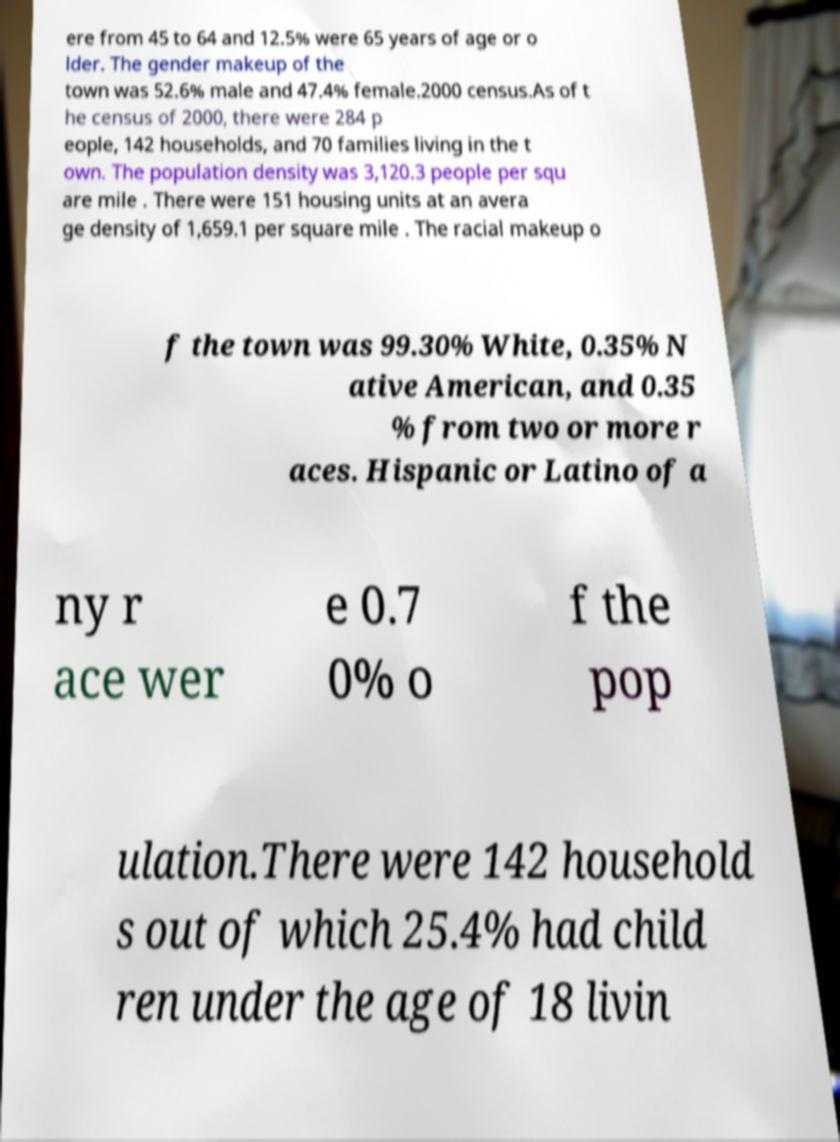Could you assist in decoding the text presented in this image and type it out clearly? ere from 45 to 64 and 12.5% were 65 years of age or o lder. The gender makeup of the town was 52.6% male and 47.4% female.2000 census.As of t he census of 2000, there were 284 p eople, 142 households, and 70 families living in the t own. The population density was 3,120.3 people per squ are mile . There were 151 housing units at an avera ge density of 1,659.1 per square mile . The racial makeup o f the town was 99.30% White, 0.35% N ative American, and 0.35 % from two or more r aces. Hispanic or Latino of a ny r ace wer e 0.7 0% o f the pop ulation.There were 142 household s out of which 25.4% had child ren under the age of 18 livin 